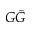Convert formula to latex. <formula><loc_0><loc_0><loc_500><loc_500>G \bar { G }</formula> 